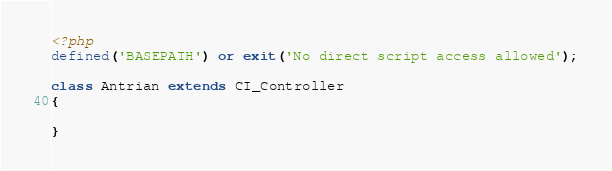Convert code to text. <code><loc_0><loc_0><loc_500><loc_500><_PHP_><?php
defined('BASEPATH') or exit('No direct script access allowed');

class Antrian extends CI_Controller
{
    
}</code> 